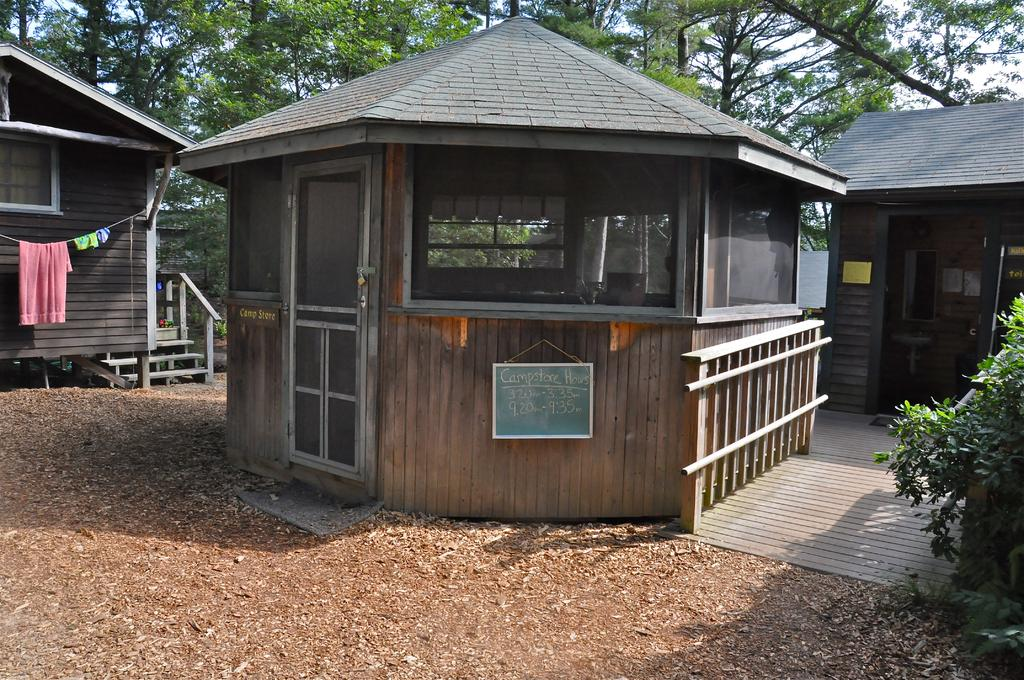What is located in the bottom right corner of the image? There are plants in the bottom right corner of the image. What structures can be seen in the middle of the image? There are sheds in the middle of the image. What type of vegetation is visible behind the sheds? There are trees visible behind the sheds. Where is the meat stored in the image? There is no meat present in the image. Can you point out the hydrant in the image? There is no hydrant present in the image. 